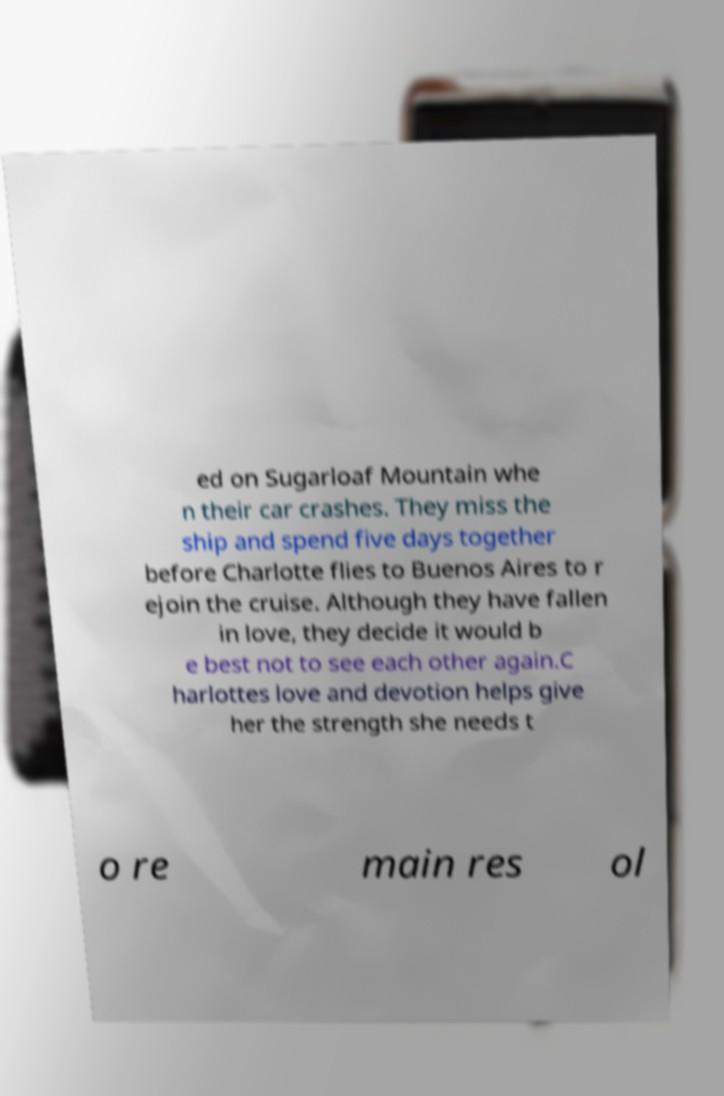Could you extract and type out the text from this image? ed on Sugarloaf Mountain whe n their car crashes. They miss the ship and spend five days together before Charlotte flies to Buenos Aires to r ejoin the cruise. Although they have fallen in love, they decide it would b e best not to see each other again.C harlottes love and devotion helps give her the strength she needs t o re main res ol 